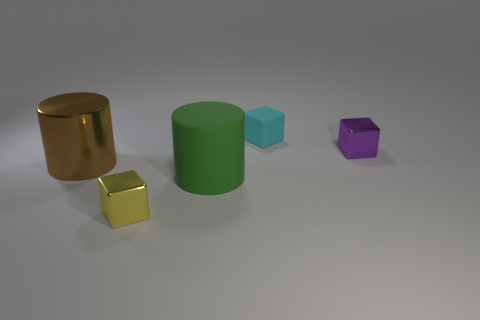What size is the cube that is in front of the purple thing?
Provide a short and direct response. Small. What size is the shiny cube that is right of the cube that is behind the tiny purple shiny cube?
Offer a terse response. Small. Is the number of large gray matte spheres greater than the number of large brown metallic objects?
Give a very brief answer. No. Is the number of large cylinders that are behind the small cyan matte object greater than the number of big green things that are left of the tiny yellow thing?
Provide a succinct answer. No. How big is the object that is both to the right of the brown metal object and on the left side of the green rubber object?
Your answer should be compact. Small. How many green things have the same size as the brown cylinder?
Provide a succinct answer. 1. Do the tiny thing that is in front of the purple thing and the big green matte object have the same shape?
Provide a short and direct response. No. Is the number of large matte cylinders that are to the right of the small cyan object less than the number of purple metal things?
Offer a terse response. Yes. Is there a shiny cube that has the same color as the rubber cylinder?
Provide a succinct answer. No. Is the shape of the large green matte object the same as the tiny object to the left of the big matte thing?
Provide a succinct answer. No. 